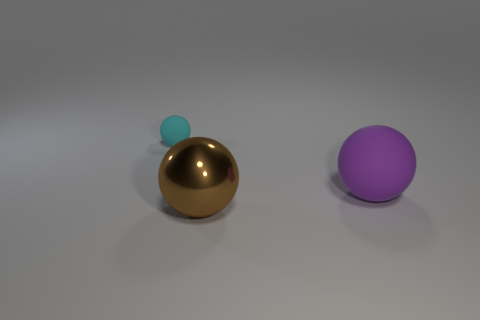Subtract all tiny balls. How many balls are left? 2 Subtract 1 spheres. How many spheres are left? 2 Add 3 big matte cylinders. How many objects exist? 6 Subtract all gray spheres. Subtract all purple cylinders. How many spheres are left? 3 Subtract all large red cubes. Subtract all brown things. How many objects are left? 2 Add 2 large purple things. How many large purple things are left? 3 Add 3 small cyan rubber objects. How many small cyan rubber objects exist? 4 Subtract 0 red balls. How many objects are left? 3 